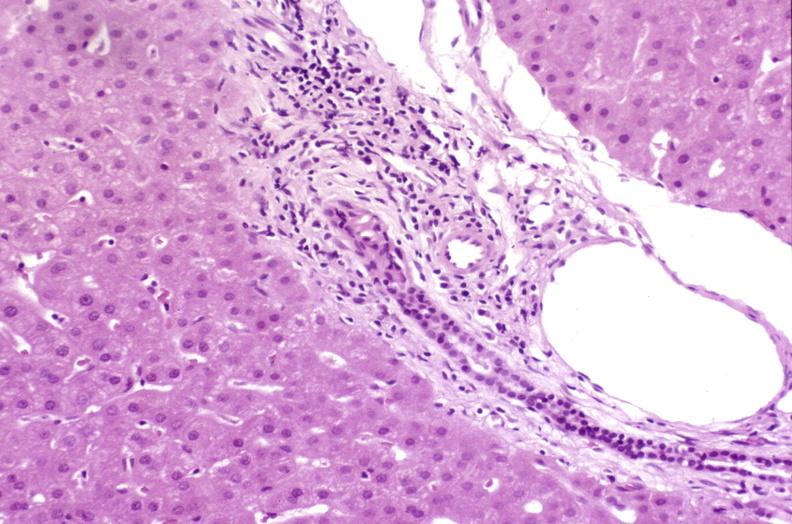s hepatobiliary present?
Answer the question using a single word or phrase. Yes 